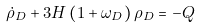<formula> <loc_0><loc_0><loc_500><loc_500>\dot { \rho } _ { D } + 3 H \left ( 1 + \omega _ { D } \right ) \rho _ { D } = - Q</formula> 